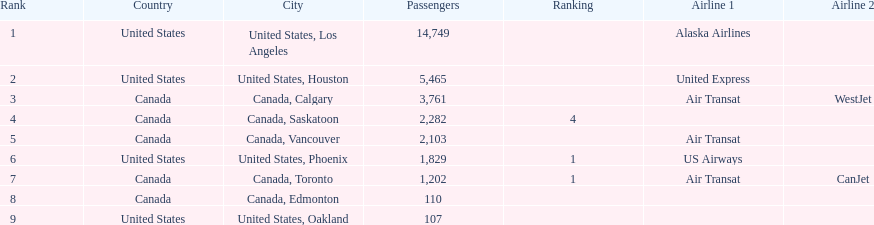How many more passengers flew to los angeles than to saskatoon from manzanillo airport in 2013? 12,467. 